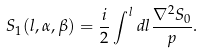Convert formula to latex. <formula><loc_0><loc_0><loc_500><loc_500>S _ { 1 } ( l , \alpha , \beta ) = \frac { i } { 2 } \int ^ { l } d l \frac { \nabla ^ { 2 } S _ { 0 } } { p } .</formula> 